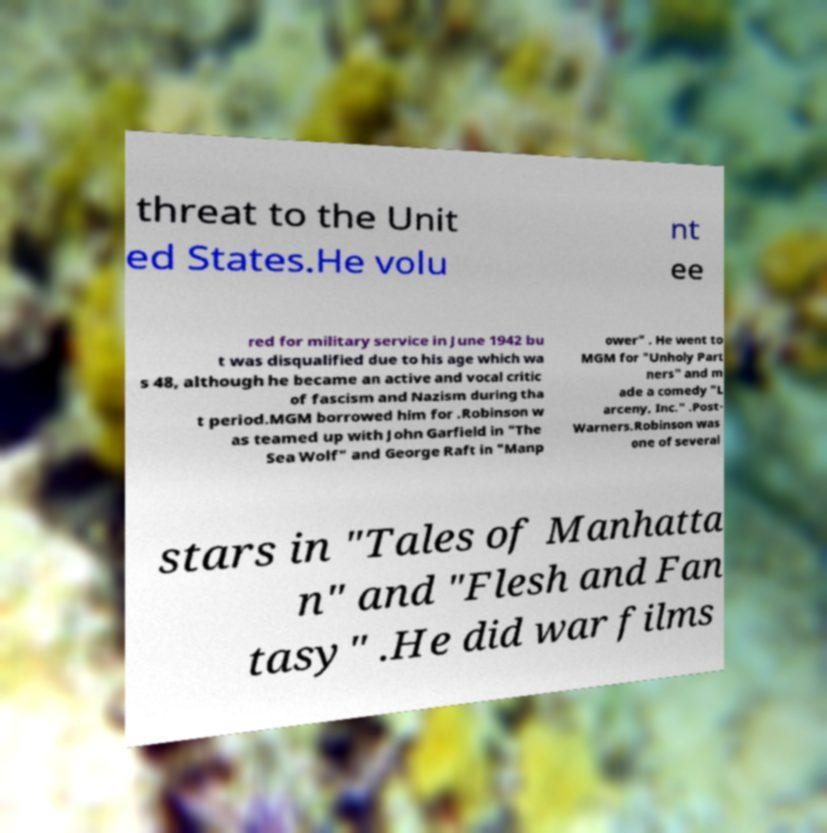Can you read and provide the text displayed in the image?This photo seems to have some interesting text. Can you extract and type it out for me? threat to the Unit ed States.He volu nt ee red for military service in June 1942 bu t was disqualified due to his age which wa s 48, although he became an active and vocal critic of fascism and Nazism during tha t period.MGM borrowed him for .Robinson w as teamed up with John Garfield in "The Sea Wolf" and George Raft in "Manp ower" . He went to MGM for "Unholy Part ners" and m ade a comedy "L arceny, Inc." .Post- Warners.Robinson was one of several stars in "Tales of Manhatta n" and "Flesh and Fan tasy" .He did war films 